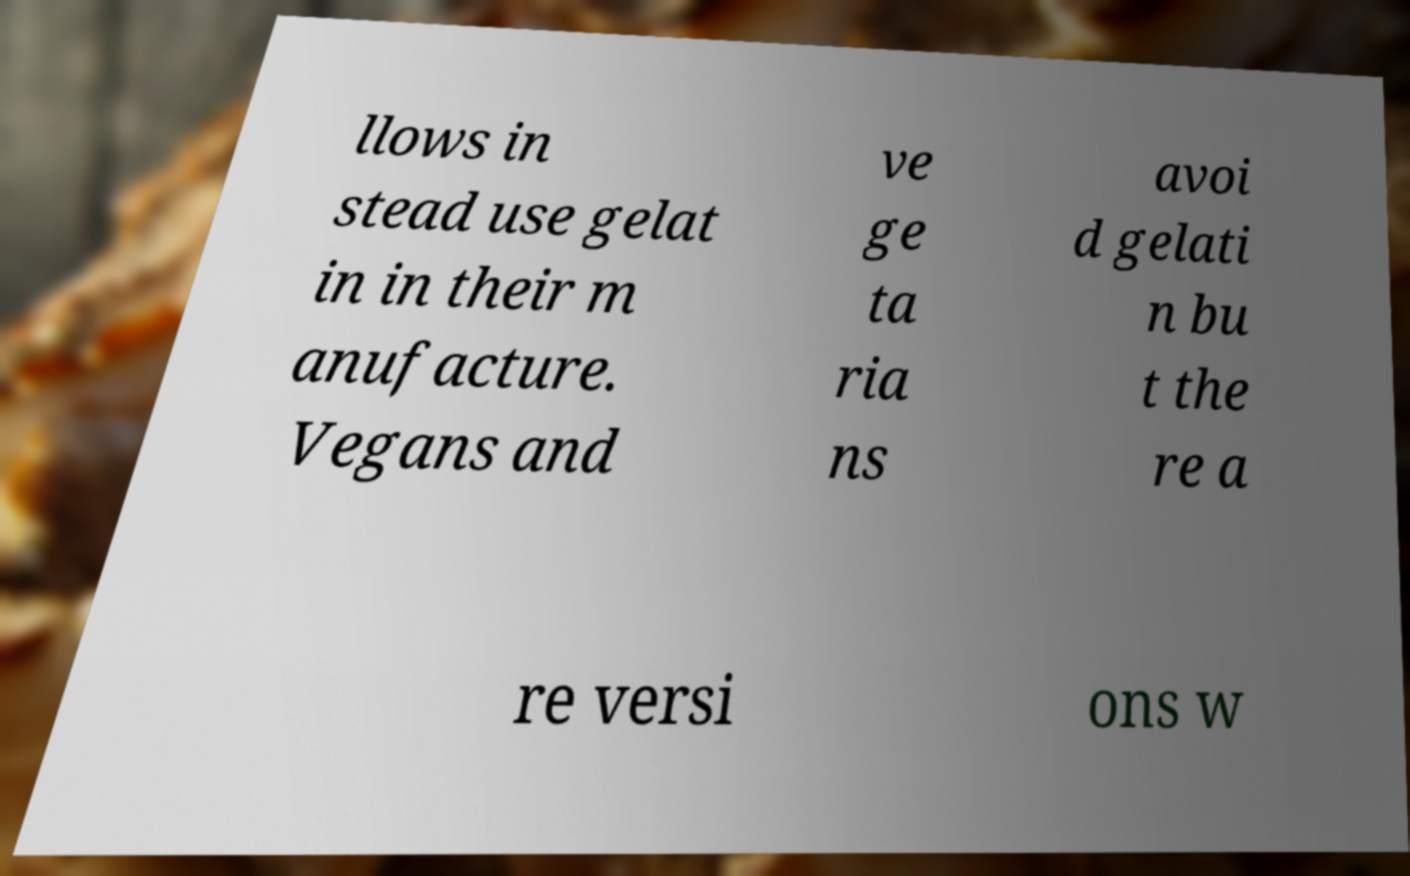Could you extract and type out the text from this image? llows in stead use gelat in in their m anufacture. Vegans and ve ge ta ria ns avoi d gelati n bu t the re a re versi ons w 